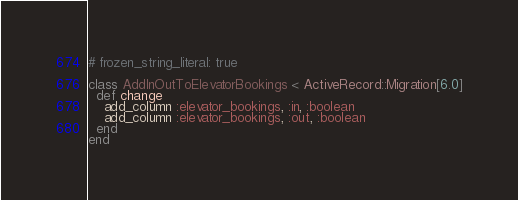<code> <loc_0><loc_0><loc_500><loc_500><_Ruby_># frozen_string_literal: true

class AddInOutToElevatorBookings < ActiveRecord::Migration[6.0]
  def change
    add_column :elevator_bookings, :in, :boolean
    add_column :elevator_bookings, :out, :boolean
  end
end
</code> 